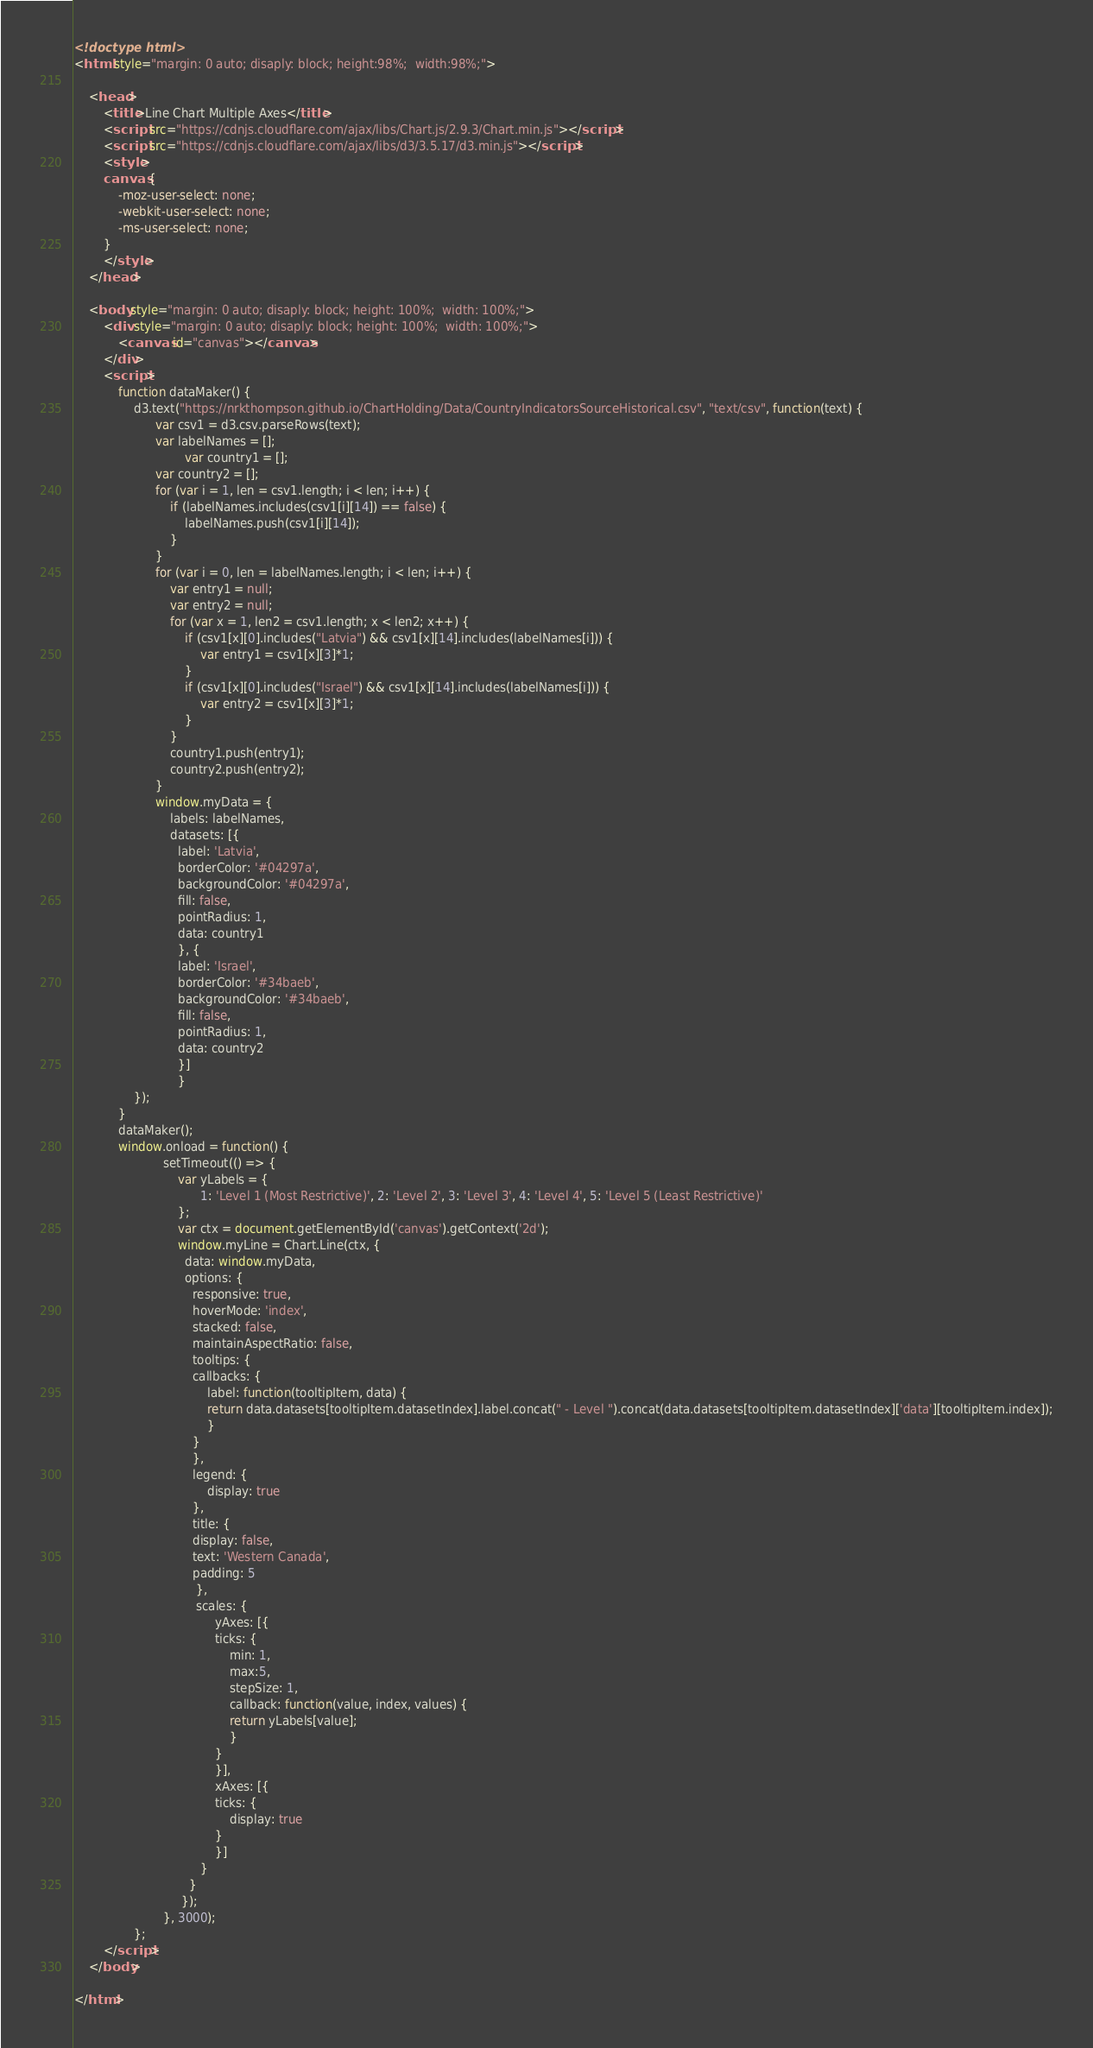Convert code to text. <code><loc_0><loc_0><loc_500><loc_500><_HTML_>
<!doctype html>
<html style="margin: 0 auto; disaply: block; height:98%;  width:98%;">

	<head>
		<title>Line Chart Multiple Axes</title>
		<script src="https://cdnjs.cloudflare.com/ajax/libs/Chart.js/2.9.3/Chart.min.js"></script>
		<script src="https://cdnjs.cloudflare.com/ajax/libs/d3/3.5.17/d3.min.js"></script>
		<style>
		canvas {
			-moz-user-select: none;
			-webkit-user-select: none;
			-ms-user-select: none;
		}
		</style>
	</head>

	<body style="margin: 0 auto; disaply: block; height: 100%;  width: 100%;">
		<div style="margin: 0 auto; disaply: block; height: 100%;  width: 100%;">
			<canvas id="canvas"></canvas>
		</div>
		<script>
			function dataMaker() {
				d3.text("https://nrkthompson.github.io/ChartHolding/Data/CountryIndicatorsSourceHistorical.csv", "text/csv", function(text) {
					  var csv1 = d3.csv.parseRows(text);
					  var labelNames = [];
            				  var country1 = [];
					  var country2 = [];
					  for (var i = 1, len = csv1.length; i < len; i++) {
						  if (labelNames.includes(csv1[i][14]) == false) {
							  labelNames.push(csv1[i][14]);
						  }
					  }
					  for (var i = 0, len = labelNames.length; i < len; i++) {
						  var entry1 = null;
						  var entry2 = null;
						  for (var x = 1, len2 = csv1.length; x < len2; x++) {
							  if (csv1[x][0].includes("Latvia") && csv1[x][14].includes(labelNames[i])) {
								  var entry1 = csv1[x][3]*1;
							  }
							  if (csv1[x][0].includes("Israel") && csv1[x][14].includes(labelNames[i])) {
								  var entry2 = csv1[x][3]*1;
							  }
						  }
						  country1.push(entry1);
						  country2.push(entry2);
					  }
					  window.myData = {
						  labels: labelNames,
						  datasets: [{
						    label: 'Latvia',
						    borderColor: '#04297a',
						    backgroundColor: '#04297a',
						    fill: false,
						    pointRadius: 1,
						    data: country1
						    }, {
						    label: 'Israel',
						    borderColor: '#34baeb',
						    backgroundColor: '#34baeb',
						    fill: false,
						    pointRadius: 1,
						    data: country2
						    }]
						    }  
				});
			}
			dataMaker();
			window.onload = function() {
						setTimeout(() => { 
							var yLabels = {
							      1: 'Level 1 (Most Restrictive)', 2: 'Level 2', 3: 'Level 3', 4: 'Level 4', 5: 'Level 5 (Least Restrictive)'
							};
							var ctx = document.getElementById('canvas').getContext('2d');
							window.myLine = Chart.Line(ctx, {
							  data: window.myData,
							  options: {
							    responsive: true,
							    hoverMode: 'index',
							    stacked: false,
							    maintainAspectRatio: false,
							    tooltips: {
								callbacks: {
								    label: function(tooltipItem, data) {
									return data.datasets[tooltipItem.datasetIndex].label.concat(" - Level ").concat(data.datasets[tooltipItem.datasetIndex]['data'][tooltipItem.index]);
								    }
								}
							    },
							    legend: {
								    display: true
							    },
							    title: {
								display: false,
								text: 'Western Canada',
								padding: 5
							     },
							     scales: {
								      yAxes: [{
									  ticks: {
									      min: 1,
									      max:5,
									      stepSize: 1,
									      callback: function(value, index, values) {
										  return yLabels[value];
									      }
									  }
								      }],
								      xAxes: [{
									  ticks: {
									      display: true
									  }
								      }]
								  }
							   }
							 });
						}, 3000);
				};
		</script>
	</body>

</html></code> 